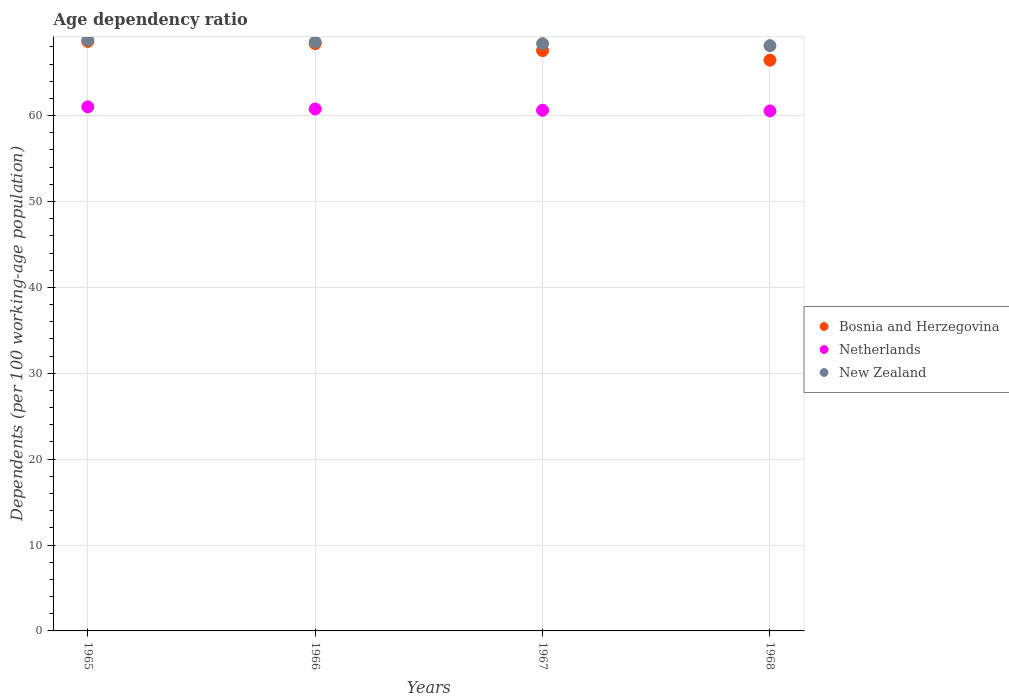How many different coloured dotlines are there?
Give a very brief answer. 3. What is the age dependency ratio in in New Zealand in 1968?
Give a very brief answer. 68.14. Across all years, what is the maximum age dependency ratio in in New Zealand?
Make the answer very short. 68.79. Across all years, what is the minimum age dependency ratio in in Netherlands?
Your response must be concise. 60.54. In which year was the age dependency ratio in in Bosnia and Herzegovina maximum?
Provide a succinct answer. 1965. In which year was the age dependency ratio in in New Zealand minimum?
Your answer should be very brief. 1968. What is the total age dependency ratio in in Netherlands in the graph?
Keep it short and to the point. 242.95. What is the difference between the age dependency ratio in in New Zealand in 1967 and that in 1968?
Make the answer very short. 0.23. What is the difference between the age dependency ratio in in Netherlands in 1967 and the age dependency ratio in in New Zealand in 1965?
Provide a succinct answer. -8.17. What is the average age dependency ratio in in Bosnia and Herzegovina per year?
Your answer should be very brief. 67.76. In the year 1967, what is the difference between the age dependency ratio in in Bosnia and Herzegovina and age dependency ratio in in New Zealand?
Offer a very short reply. -0.81. In how many years, is the age dependency ratio in in Netherlands greater than 66 %?
Your answer should be compact. 0. What is the ratio of the age dependency ratio in in Netherlands in 1967 to that in 1968?
Give a very brief answer. 1. What is the difference between the highest and the second highest age dependency ratio in in Netherlands?
Provide a short and direct response. 0.26. What is the difference between the highest and the lowest age dependency ratio in in Bosnia and Herzegovina?
Keep it short and to the point. 2.19. What is the difference between two consecutive major ticks on the Y-axis?
Offer a very short reply. 10. Does the graph contain any zero values?
Offer a terse response. No. Does the graph contain grids?
Offer a very short reply. Yes. Where does the legend appear in the graph?
Offer a terse response. Center right. How many legend labels are there?
Provide a short and direct response. 3. How are the legend labels stacked?
Your answer should be very brief. Vertical. What is the title of the graph?
Make the answer very short. Age dependency ratio. Does "India" appear as one of the legend labels in the graph?
Your answer should be very brief. No. What is the label or title of the X-axis?
Offer a very short reply. Years. What is the label or title of the Y-axis?
Make the answer very short. Dependents (per 100 working-age population). What is the Dependents (per 100 working-age population) of Bosnia and Herzegovina in 1965?
Keep it short and to the point. 68.64. What is the Dependents (per 100 working-age population) in Netherlands in 1965?
Offer a very short reply. 61.02. What is the Dependents (per 100 working-age population) in New Zealand in 1965?
Provide a succinct answer. 68.79. What is the Dependents (per 100 working-age population) of Bosnia and Herzegovina in 1966?
Your response must be concise. 68.38. What is the Dependents (per 100 working-age population) of Netherlands in 1966?
Offer a terse response. 60.77. What is the Dependents (per 100 working-age population) in New Zealand in 1966?
Provide a succinct answer. 68.56. What is the Dependents (per 100 working-age population) of Bosnia and Herzegovina in 1967?
Your response must be concise. 67.56. What is the Dependents (per 100 working-age population) of Netherlands in 1967?
Your answer should be very brief. 60.62. What is the Dependents (per 100 working-age population) in New Zealand in 1967?
Provide a short and direct response. 68.37. What is the Dependents (per 100 working-age population) of Bosnia and Herzegovina in 1968?
Provide a short and direct response. 66.45. What is the Dependents (per 100 working-age population) in Netherlands in 1968?
Your answer should be very brief. 60.54. What is the Dependents (per 100 working-age population) of New Zealand in 1968?
Provide a short and direct response. 68.14. Across all years, what is the maximum Dependents (per 100 working-age population) in Bosnia and Herzegovina?
Offer a terse response. 68.64. Across all years, what is the maximum Dependents (per 100 working-age population) in Netherlands?
Your answer should be compact. 61.02. Across all years, what is the maximum Dependents (per 100 working-age population) in New Zealand?
Provide a succinct answer. 68.79. Across all years, what is the minimum Dependents (per 100 working-age population) of Bosnia and Herzegovina?
Your answer should be compact. 66.45. Across all years, what is the minimum Dependents (per 100 working-age population) in Netherlands?
Provide a short and direct response. 60.54. Across all years, what is the minimum Dependents (per 100 working-age population) in New Zealand?
Make the answer very short. 68.14. What is the total Dependents (per 100 working-age population) of Bosnia and Herzegovina in the graph?
Your answer should be compact. 271.03. What is the total Dependents (per 100 working-age population) of Netherlands in the graph?
Provide a short and direct response. 242.95. What is the total Dependents (per 100 working-age population) of New Zealand in the graph?
Your answer should be compact. 273.86. What is the difference between the Dependents (per 100 working-age population) in Bosnia and Herzegovina in 1965 and that in 1966?
Keep it short and to the point. 0.26. What is the difference between the Dependents (per 100 working-age population) in Netherlands in 1965 and that in 1966?
Make the answer very short. 0.26. What is the difference between the Dependents (per 100 working-age population) in New Zealand in 1965 and that in 1966?
Provide a short and direct response. 0.22. What is the difference between the Dependents (per 100 working-age population) in Bosnia and Herzegovina in 1965 and that in 1967?
Your answer should be compact. 1.07. What is the difference between the Dependents (per 100 working-age population) of Netherlands in 1965 and that in 1967?
Your response must be concise. 0.4. What is the difference between the Dependents (per 100 working-age population) in New Zealand in 1965 and that in 1967?
Ensure brevity in your answer.  0.41. What is the difference between the Dependents (per 100 working-age population) of Bosnia and Herzegovina in 1965 and that in 1968?
Ensure brevity in your answer.  2.19. What is the difference between the Dependents (per 100 working-age population) of Netherlands in 1965 and that in 1968?
Offer a terse response. 0.48. What is the difference between the Dependents (per 100 working-age population) of New Zealand in 1965 and that in 1968?
Provide a short and direct response. 0.65. What is the difference between the Dependents (per 100 working-age population) of Bosnia and Herzegovina in 1966 and that in 1967?
Offer a very short reply. 0.82. What is the difference between the Dependents (per 100 working-age population) of Netherlands in 1966 and that in 1967?
Ensure brevity in your answer.  0.15. What is the difference between the Dependents (per 100 working-age population) in New Zealand in 1966 and that in 1967?
Your answer should be very brief. 0.19. What is the difference between the Dependents (per 100 working-age population) in Bosnia and Herzegovina in 1966 and that in 1968?
Your answer should be compact. 1.93. What is the difference between the Dependents (per 100 working-age population) of Netherlands in 1966 and that in 1968?
Offer a very short reply. 0.22. What is the difference between the Dependents (per 100 working-age population) in New Zealand in 1966 and that in 1968?
Offer a very short reply. 0.42. What is the difference between the Dependents (per 100 working-age population) in Bosnia and Herzegovina in 1967 and that in 1968?
Provide a short and direct response. 1.11. What is the difference between the Dependents (per 100 working-age population) of Netherlands in 1967 and that in 1968?
Offer a very short reply. 0.08. What is the difference between the Dependents (per 100 working-age population) in New Zealand in 1967 and that in 1968?
Make the answer very short. 0.23. What is the difference between the Dependents (per 100 working-age population) in Bosnia and Herzegovina in 1965 and the Dependents (per 100 working-age population) in Netherlands in 1966?
Make the answer very short. 7.87. What is the difference between the Dependents (per 100 working-age population) of Bosnia and Herzegovina in 1965 and the Dependents (per 100 working-age population) of New Zealand in 1966?
Your answer should be compact. 0.07. What is the difference between the Dependents (per 100 working-age population) in Netherlands in 1965 and the Dependents (per 100 working-age population) in New Zealand in 1966?
Give a very brief answer. -7.54. What is the difference between the Dependents (per 100 working-age population) of Bosnia and Herzegovina in 1965 and the Dependents (per 100 working-age population) of Netherlands in 1967?
Offer a very short reply. 8.02. What is the difference between the Dependents (per 100 working-age population) of Bosnia and Herzegovina in 1965 and the Dependents (per 100 working-age population) of New Zealand in 1967?
Provide a succinct answer. 0.27. What is the difference between the Dependents (per 100 working-age population) in Netherlands in 1965 and the Dependents (per 100 working-age population) in New Zealand in 1967?
Your response must be concise. -7.35. What is the difference between the Dependents (per 100 working-age population) in Bosnia and Herzegovina in 1965 and the Dependents (per 100 working-age population) in Netherlands in 1968?
Offer a very short reply. 8.09. What is the difference between the Dependents (per 100 working-age population) of Bosnia and Herzegovina in 1965 and the Dependents (per 100 working-age population) of New Zealand in 1968?
Offer a very short reply. 0.5. What is the difference between the Dependents (per 100 working-age population) in Netherlands in 1965 and the Dependents (per 100 working-age population) in New Zealand in 1968?
Ensure brevity in your answer.  -7.12. What is the difference between the Dependents (per 100 working-age population) in Bosnia and Herzegovina in 1966 and the Dependents (per 100 working-age population) in Netherlands in 1967?
Your response must be concise. 7.76. What is the difference between the Dependents (per 100 working-age population) in Bosnia and Herzegovina in 1966 and the Dependents (per 100 working-age population) in New Zealand in 1967?
Your answer should be compact. 0.01. What is the difference between the Dependents (per 100 working-age population) of Netherlands in 1966 and the Dependents (per 100 working-age population) of New Zealand in 1967?
Offer a very short reply. -7.61. What is the difference between the Dependents (per 100 working-age population) of Bosnia and Herzegovina in 1966 and the Dependents (per 100 working-age population) of Netherlands in 1968?
Your answer should be very brief. 7.84. What is the difference between the Dependents (per 100 working-age population) in Bosnia and Herzegovina in 1966 and the Dependents (per 100 working-age population) in New Zealand in 1968?
Make the answer very short. 0.24. What is the difference between the Dependents (per 100 working-age population) of Netherlands in 1966 and the Dependents (per 100 working-age population) of New Zealand in 1968?
Ensure brevity in your answer.  -7.37. What is the difference between the Dependents (per 100 working-age population) of Bosnia and Herzegovina in 1967 and the Dependents (per 100 working-age population) of Netherlands in 1968?
Your answer should be compact. 7.02. What is the difference between the Dependents (per 100 working-age population) in Bosnia and Herzegovina in 1967 and the Dependents (per 100 working-age population) in New Zealand in 1968?
Your response must be concise. -0.58. What is the difference between the Dependents (per 100 working-age population) in Netherlands in 1967 and the Dependents (per 100 working-age population) in New Zealand in 1968?
Offer a terse response. -7.52. What is the average Dependents (per 100 working-age population) in Bosnia and Herzegovina per year?
Keep it short and to the point. 67.76. What is the average Dependents (per 100 working-age population) of Netherlands per year?
Make the answer very short. 60.74. What is the average Dependents (per 100 working-age population) in New Zealand per year?
Provide a succinct answer. 68.46. In the year 1965, what is the difference between the Dependents (per 100 working-age population) of Bosnia and Herzegovina and Dependents (per 100 working-age population) of Netherlands?
Ensure brevity in your answer.  7.62. In the year 1965, what is the difference between the Dependents (per 100 working-age population) of Bosnia and Herzegovina and Dependents (per 100 working-age population) of New Zealand?
Give a very brief answer. -0.15. In the year 1965, what is the difference between the Dependents (per 100 working-age population) of Netherlands and Dependents (per 100 working-age population) of New Zealand?
Provide a succinct answer. -7.77. In the year 1966, what is the difference between the Dependents (per 100 working-age population) in Bosnia and Herzegovina and Dependents (per 100 working-age population) in Netherlands?
Your answer should be compact. 7.61. In the year 1966, what is the difference between the Dependents (per 100 working-age population) in Bosnia and Herzegovina and Dependents (per 100 working-age population) in New Zealand?
Give a very brief answer. -0.18. In the year 1966, what is the difference between the Dependents (per 100 working-age population) of Netherlands and Dependents (per 100 working-age population) of New Zealand?
Offer a very short reply. -7.8. In the year 1967, what is the difference between the Dependents (per 100 working-age population) of Bosnia and Herzegovina and Dependents (per 100 working-age population) of Netherlands?
Your answer should be very brief. 6.94. In the year 1967, what is the difference between the Dependents (per 100 working-age population) of Bosnia and Herzegovina and Dependents (per 100 working-age population) of New Zealand?
Provide a short and direct response. -0.81. In the year 1967, what is the difference between the Dependents (per 100 working-age population) of Netherlands and Dependents (per 100 working-age population) of New Zealand?
Give a very brief answer. -7.75. In the year 1968, what is the difference between the Dependents (per 100 working-age population) in Bosnia and Herzegovina and Dependents (per 100 working-age population) in Netherlands?
Your answer should be compact. 5.91. In the year 1968, what is the difference between the Dependents (per 100 working-age population) of Bosnia and Herzegovina and Dependents (per 100 working-age population) of New Zealand?
Give a very brief answer. -1.69. In the year 1968, what is the difference between the Dependents (per 100 working-age population) of Netherlands and Dependents (per 100 working-age population) of New Zealand?
Your response must be concise. -7.6. What is the ratio of the Dependents (per 100 working-age population) in Netherlands in 1965 to that in 1966?
Ensure brevity in your answer.  1. What is the ratio of the Dependents (per 100 working-age population) in New Zealand in 1965 to that in 1966?
Provide a short and direct response. 1. What is the ratio of the Dependents (per 100 working-age population) of Bosnia and Herzegovina in 1965 to that in 1967?
Provide a succinct answer. 1.02. What is the ratio of the Dependents (per 100 working-age population) in Netherlands in 1965 to that in 1967?
Offer a very short reply. 1.01. What is the ratio of the Dependents (per 100 working-age population) of New Zealand in 1965 to that in 1967?
Provide a short and direct response. 1.01. What is the ratio of the Dependents (per 100 working-age population) in Bosnia and Herzegovina in 1965 to that in 1968?
Keep it short and to the point. 1.03. What is the ratio of the Dependents (per 100 working-age population) in Netherlands in 1965 to that in 1968?
Offer a very short reply. 1.01. What is the ratio of the Dependents (per 100 working-age population) of New Zealand in 1965 to that in 1968?
Offer a very short reply. 1.01. What is the ratio of the Dependents (per 100 working-age population) in Bosnia and Herzegovina in 1966 to that in 1967?
Offer a very short reply. 1.01. What is the ratio of the Dependents (per 100 working-age population) of Netherlands in 1966 to that in 1967?
Offer a very short reply. 1. What is the ratio of the Dependents (per 100 working-age population) in Bosnia and Herzegovina in 1966 to that in 1968?
Your answer should be compact. 1.03. What is the ratio of the Dependents (per 100 working-age population) in Netherlands in 1966 to that in 1968?
Give a very brief answer. 1. What is the ratio of the Dependents (per 100 working-age population) in Bosnia and Herzegovina in 1967 to that in 1968?
Give a very brief answer. 1.02. What is the difference between the highest and the second highest Dependents (per 100 working-age population) of Bosnia and Herzegovina?
Ensure brevity in your answer.  0.26. What is the difference between the highest and the second highest Dependents (per 100 working-age population) in Netherlands?
Offer a very short reply. 0.26. What is the difference between the highest and the second highest Dependents (per 100 working-age population) of New Zealand?
Offer a very short reply. 0.22. What is the difference between the highest and the lowest Dependents (per 100 working-age population) in Bosnia and Herzegovina?
Keep it short and to the point. 2.19. What is the difference between the highest and the lowest Dependents (per 100 working-age population) of Netherlands?
Your answer should be very brief. 0.48. What is the difference between the highest and the lowest Dependents (per 100 working-age population) in New Zealand?
Your answer should be very brief. 0.65. 